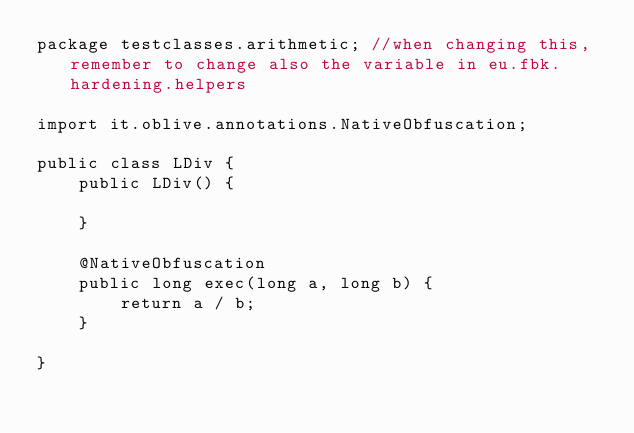<code> <loc_0><loc_0><loc_500><loc_500><_Java_>package testclasses.arithmetic; //when changing this, remember to change also the variable in eu.fbk.hardening.helpers

import it.oblive.annotations.NativeObfuscation;

public class LDiv {
    public LDiv() {

    }

    @NativeObfuscation
    public long exec(long a, long b) {
        return a / b;
    }

}
</code> 